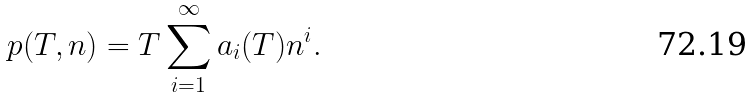<formula> <loc_0><loc_0><loc_500><loc_500>p ( T , n ) = T \sum _ { i = 1 } ^ { \infty } a _ { i } ( T ) n ^ { i } .</formula> 